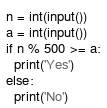<code> <loc_0><loc_0><loc_500><loc_500><_Python_>n = int(input())
a = int(input())
if n % 500 >= a:
  print('Yes')
else:
  print('No')</code> 